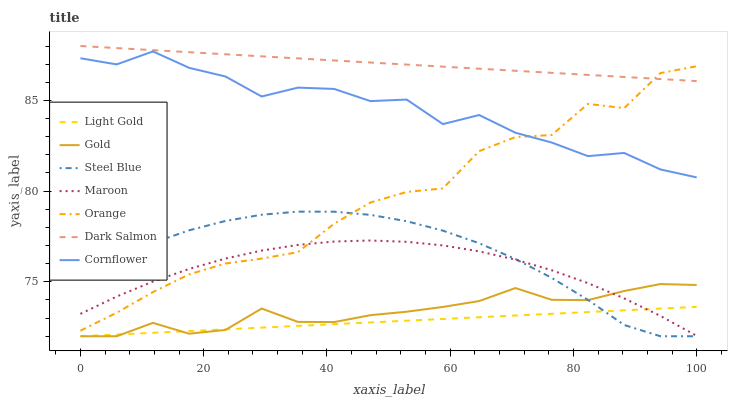Does Light Gold have the minimum area under the curve?
Answer yes or no. Yes. Does Dark Salmon have the maximum area under the curve?
Answer yes or no. Yes. Does Gold have the minimum area under the curve?
Answer yes or no. No. Does Gold have the maximum area under the curve?
Answer yes or no. No. Is Dark Salmon the smoothest?
Answer yes or no. Yes. Is Cornflower the roughest?
Answer yes or no. Yes. Is Gold the smoothest?
Answer yes or no. No. Is Gold the roughest?
Answer yes or no. No. Does Gold have the lowest value?
Answer yes or no. Yes. Does Maroon have the lowest value?
Answer yes or no. No. Does Dark Salmon have the highest value?
Answer yes or no. Yes. Does Gold have the highest value?
Answer yes or no. No. Is Light Gold less than Orange?
Answer yes or no. Yes. Is Dark Salmon greater than Light Gold?
Answer yes or no. Yes. Does Maroon intersect Steel Blue?
Answer yes or no. Yes. Is Maroon less than Steel Blue?
Answer yes or no. No. Is Maroon greater than Steel Blue?
Answer yes or no. No. Does Light Gold intersect Orange?
Answer yes or no. No. 